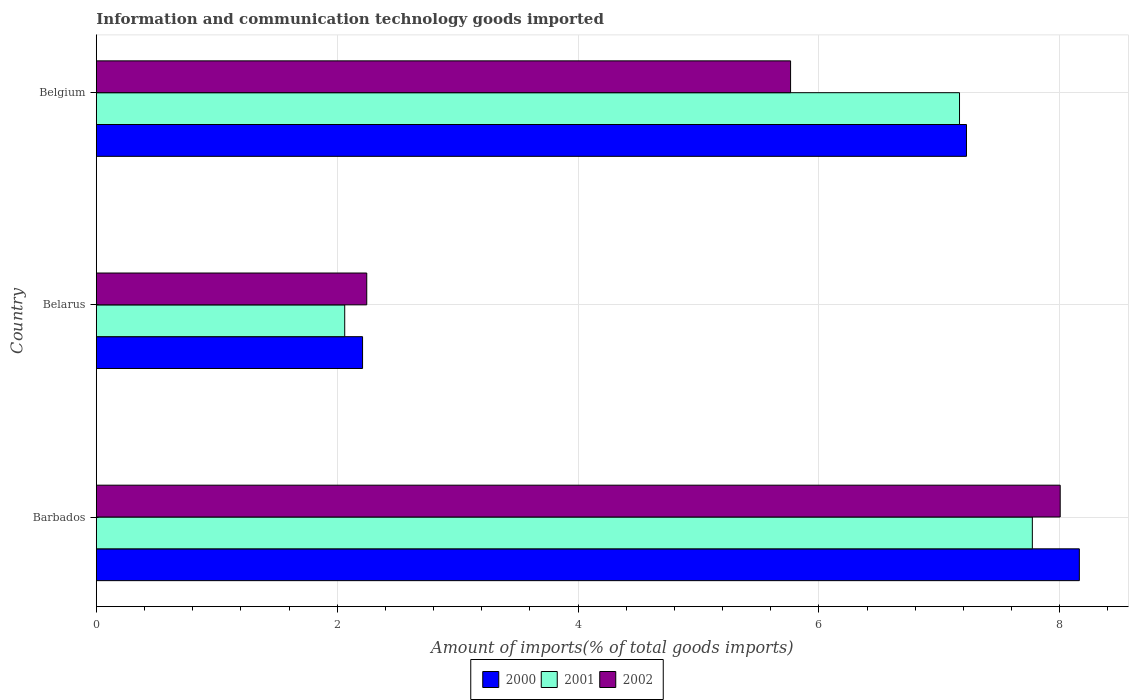How many different coloured bars are there?
Provide a short and direct response. 3. How many groups of bars are there?
Make the answer very short. 3. How many bars are there on the 1st tick from the top?
Offer a terse response. 3. How many bars are there on the 3rd tick from the bottom?
Your answer should be very brief. 3. What is the label of the 2nd group of bars from the top?
Offer a terse response. Belarus. What is the amount of goods imported in 2002 in Belarus?
Provide a succinct answer. 2.25. Across all countries, what is the maximum amount of goods imported in 2000?
Provide a succinct answer. 8.16. Across all countries, what is the minimum amount of goods imported in 2002?
Provide a short and direct response. 2.25. In which country was the amount of goods imported in 2001 maximum?
Offer a very short reply. Barbados. In which country was the amount of goods imported in 2002 minimum?
Your answer should be very brief. Belarus. What is the total amount of goods imported in 2001 in the graph?
Make the answer very short. 17. What is the difference between the amount of goods imported in 2000 in Belarus and that in Belgium?
Ensure brevity in your answer.  -5.02. What is the difference between the amount of goods imported in 2002 in Belarus and the amount of goods imported in 2000 in Belgium?
Keep it short and to the point. -4.98. What is the average amount of goods imported in 2001 per country?
Your answer should be compact. 5.67. What is the difference between the amount of goods imported in 2002 and amount of goods imported in 2000 in Barbados?
Offer a terse response. -0.16. In how many countries, is the amount of goods imported in 2001 greater than 6.4 %?
Your answer should be very brief. 2. What is the ratio of the amount of goods imported in 2002 in Barbados to that in Belarus?
Your answer should be very brief. 3.56. Is the difference between the amount of goods imported in 2002 in Barbados and Belgium greater than the difference between the amount of goods imported in 2000 in Barbados and Belgium?
Provide a short and direct response. Yes. What is the difference between the highest and the second highest amount of goods imported in 2000?
Your answer should be compact. 0.94. What is the difference between the highest and the lowest amount of goods imported in 2002?
Your response must be concise. 5.76. Is the sum of the amount of goods imported in 2000 in Belarus and Belgium greater than the maximum amount of goods imported in 2001 across all countries?
Give a very brief answer. Yes. What does the 2nd bar from the bottom in Barbados represents?
Give a very brief answer. 2001. How many bars are there?
Offer a terse response. 9. Are all the bars in the graph horizontal?
Make the answer very short. Yes. How many countries are there in the graph?
Your answer should be very brief. 3. What is the difference between two consecutive major ticks on the X-axis?
Make the answer very short. 2. Does the graph contain any zero values?
Give a very brief answer. No. Does the graph contain grids?
Your response must be concise. Yes. What is the title of the graph?
Keep it short and to the point. Information and communication technology goods imported. Does "1988" appear as one of the legend labels in the graph?
Provide a succinct answer. No. What is the label or title of the X-axis?
Your response must be concise. Amount of imports(% of total goods imports). What is the Amount of imports(% of total goods imports) in 2000 in Barbados?
Keep it short and to the point. 8.16. What is the Amount of imports(% of total goods imports) in 2001 in Barbados?
Your answer should be compact. 7.77. What is the Amount of imports(% of total goods imports) in 2002 in Barbados?
Offer a very short reply. 8. What is the Amount of imports(% of total goods imports) of 2000 in Belarus?
Provide a short and direct response. 2.21. What is the Amount of imports(% of total goods imports) in 2001 in Belarus?
Offer a very short reply. 2.06. What is the Amount of imports(% of total goods imports) in 2002 in Belarus?
Your response must be concise. 2.25. What is the Amount of imports(% of total goods imports) of 2000 in Belgium?
Offer a terse response. 7.23. What is the Amount of imports(% of total goods imports) of 2001 in Belgium?
Provide a short and direct response. 7.17. What is the Amount of imports(% of total goods imports) of 2002 in Belgium?
Provide a short and direct response. 5.76. Across all countries, what is the maximum Amount of imports(% of total goods imports) in 2000?
Keep it short and to the point. 8.16. Across all countries, what is the maximum Amount of imports(% of total goods imports) in 2001?
Your answer should be compact. 7.77. Across all countries, what is the maximum Amount of imports(% of total goods imports) in 2002?
Keep it short and to the point. 8. Across all countries, what is the minimum Amount of imports(% of total goods imports) of 2000?
Your response must be concise. 2.21. Across all countries, what is the minimum Amount of imports(% of total goods imports) of 2001?
Make the answer very short. 2.06. Across all countries, what is the minimum Amount of imports(% of total goods imports) of 2002?
Offer a terse response. 2.25. What is the total Amount of imports(% of total goods imports) in 2000 in the graph?
Make the answer very short. 17.6. What is the total Amount of imports(% of total goods imports) in 2001 in the graph?
Your answer should be compact. 17. What is the total Amount of imports(% of total goods imports) in 2002 in the graph?
Provide a succinct answer. 16.01. What is the difference between the Amount of imports(% of total goods imports) of 2000 in Barbados and that in Belarus?
Your answer should be compact. 5.95. What is the difference between the Amount of imports(% of total goods imports) of 2001 in Barbados and that in Belarus?
Make the answer very short. 5.71. What is the difference between the Amount of imports(% of total goods imports) in 2002 in Barbados and that in Belarus?
Provide a short and direct response. 5.76. What is the difference between the Amount of imports(% of total goods imports) in 2000 in Barbados and that in Belgium?
Give a very brief answer. 0.94. What is the difference between the Amount of imports(% of total goods imports) of 2001 in Barbados and that in Belgium?
Offer a terse response. 0.6. What is the difference between the Amount of imports(% of total goods imports) in 2002 in Barbados and that in Belgium?
Your answer should be compact. 2.24. What is the difference between the Amount of imports(% of total goods imports) in 2000 in Belarus and that in Belgium?
Provide a short and direct response. -5.01. What is the difference between the Amount of imports(% of total goods imports) in 2001 in Belarus and that in Belgium?
Your answer should be very brief. -5.11. What is the difference between the Amount of imports(% of total goods imports) of 2002 in Belarus and that in Belgium?
Provide a succinct answer. -3.52. What is the difference between the Amount of imports(% of total goods imports) in 2000 in Barbados and the Amount of imports(% of total goods imports) in 2001 in Belarus?
Make the answer very short. 6.1. What is the difference between the Amount of imports(% of total goods imports) of 2000 in Barbados and the Amount of imports(% of total goods imports) of 2002 in Belarus?
Your response must be concise. 5.92. What is the difference between the Amount of imports(% of total goods imports) in 2001 in Barbados and the Amount of imports(% of total goods imports) in 2002 in Belarus?
Make the answer very short. 5.53. What is the difference between the Amount of imports(% of total goods imports) of 2000 in Barbados and the Amount of imports(% of total goods imports) of 2001 in Belgium?
Make the answer very short. 1. What is the difference between the Amount of imports(% of total goods imports) of 2000 in Barbados and the Amount of imports(% of total goods imports) of 2002 in Belgium?
Your answer should be compact. 2.4. What is the difference between the Amount of imports(% of total goods imports) of 2001 in Barbados and the Amount of imports(% of total goods imports) of 2002 in Belgium?
Give a very brief answer. 2.01. What is the difference between the Amount of imports(% of total goods imports) in 2000 in Belarus and the Amount of imports(% of total goods imports) in 2001 in Belgium?
Your response must be concise. -4.96. What is the difference between the Amount of imports(% of total goods imports) in 2000 in Belarus and the Amount of imports(% of total goods imports) in 2002 in Belgium?
Ensure brevity in your answer.  -3.55. What is the difference between the Amount of imports(% of total goods imports) of 2001 in Belarus and the Amount of imports(% of total goods imports) of 2002 in Belgium?
Make the answer very short. -3.7. What is the average Amount of imports(% of total goods imports) of 2000 per country?
Provide a succinct answer. 5.87. What is the average Amount of imports(% of total goods imports) in 2001 per country?
Provide a succinct answer. 5.67. What is the average Amount of imports(% of total goods imports) of 2002 per country?
Ensure brevity in your answer.  5.34. What is the difference between the Amount of imports(% of total goods imports) in 2000 and Amount of imports(% of total goods imports) in 2001 in Barbados?
Offer a terse response. 0.39. What is the difference between the Amount of imports(% of total goods imports) of 2000 and Amount of imports(% of total goods imports) of 2002 in Barbados?
Give a very brief answer. 0.16. What is the difference between the Amount of imports(% of total goods imports) of 2001 and Amount of imports(% of total goods imports) of 2002 in Barbados?
Offer a very short reply. -0.23. What is the difference between the Amount of imports(% of total goods imports) of 2000 and Amount of imports(% of total goods imports) of 2001 in Belarus?
Your answer should be very brief. 0.15. What is the difference between the Amount of imports(% of total goods imports) in 2000 and Amount of imports(% of total goods imports) in 2002 in Belarus?
Your answer should be compact. -0.03. What is the difference between the Amount of imports(% of total goods imports) in 2001 and Amount of imports(% of total goods imports) in 2002 in Belarus?
Provide a short and direct response. -0.18. What is the difference between the Amount of imports(% of total goods imports) in 2000 and Amount of imports(% of total goods imports) in 2001 in Belgium?
Your response must be concise. 0.06. What is the difference between the Amount of imports(% of total goods imports) in 2000 and Amount of imports(% of total goods imports) in 2002 in Belgium?
Your answer should be very brief. 1.46. What is the difference between the Amount of imports(% of total goods imports) in 2001 and Amount of imports(% of total goods imports) in 2002 in Belgium?
Offer a terse response. 1.4. What is the ratio of the Amount of imports(% of total goods imports) of 2000 in Barbados to that in Belarus?
Your answer should be compact. 3.69. What is the ratio of the Amount of imports(% of total goods imports) in 2001 in Barbados to that in Belarus?
Your answer should be very brief. 3.77. What is the ratio of the Amount of imports(% of total goods imports) in 2002 in Barbados to that in Belarus?
Keep it short and to the point. 3.56. What is the ratio of the Amount of imports(% of total goods imports) in 2000 in Barbados to that in Belgium?
Ensure brevity in your answer.  1.13. What is the ratio of the Amount of imports(% of total goods imports) of 2001 in Barbados to that in Belgium?
Your answer should be compact. 1.08. What is the ratio of the Amount of imports(% of total goods imports) of 2002 in Barbados to that in Belgium?
Provide a succinct answer. 1.39. What is the ratio of the Amount of imports(% of total goods imports) of 2000 in Belarus to that in Belgium?
Give a very brief answer. 0.31. What is the ratio of the Amount of imports(% of total goods imports) in 2001 in Belarus to that in Belgium?
Keep it short and to the point. 0.29. What is the ratio of the Amount of imports(% of total goods imports) of 2002 in Belarus to that in Belgium?
Offer a very short reply. 0.39. What is the difference between the highest and the second highest Amount of imports(% of total goods imports) of 2000?
Your answer should be compact. 0.94. What is the difference between the highest and the second highest Amount of imports(% of total goods imports) in 2001?
Keep it short and to the point. 0.6. What is the difference between the highest and the second highest Amount of imports(% of total goods imports) in 2002?
Provide a short and direct response. 2.24. What is the difference between the highest and the lowest Amount of imports(% of total goods imports) in 2000?
Keep it short and to the point. 5.95. What is the difference between the highest and the lowest Amount of imports(% of total goods imports) in 2001?
Offer a terse response. 5.71. What is the difference between the highest and the lowest Amount of imports(% of total goods imports) in 2002?
Offer a terse response. 5.76. 